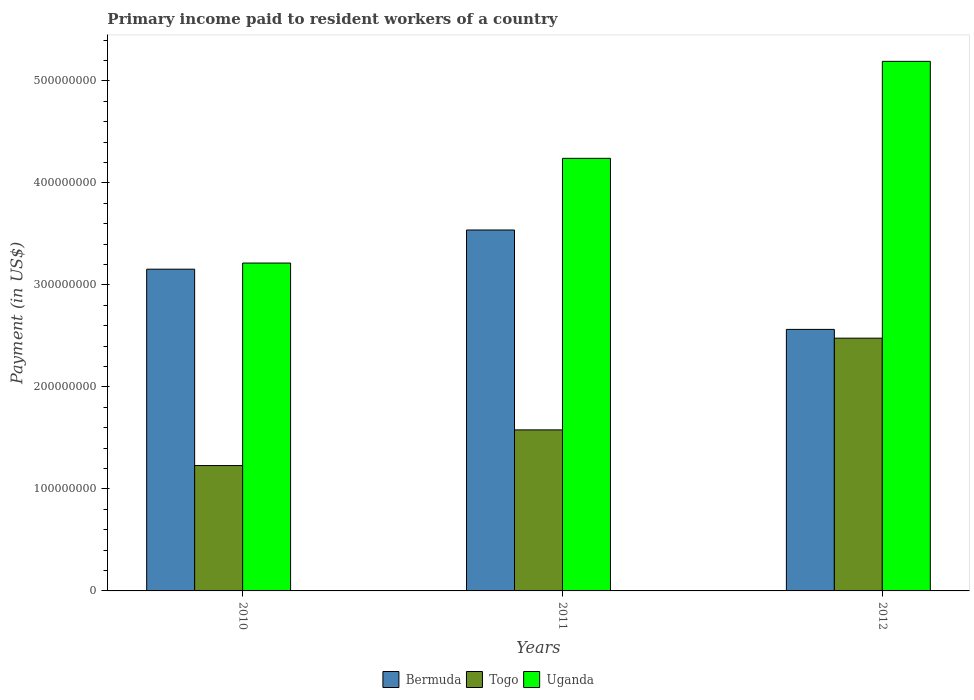What is the label of the 3rd group of bars from the left?
Provide a short and direct response. 2012. What is the amount paid to workers in Uganda in 2012?
Make the answer very short. 5.19e+08. Across all years, what is the maximum amount paid to workers in Bermuda?
Your answer should be compact. 3.54e+08. Across all years, what is the minimum amount paid to workers in Uganda?
Your answer should be very brief. 3.21e+08. What is the total amount paid to workers in Uganda in the graph?
Your answer should be compact. 1.26e+09. What is the difference between the amount paid to workers in Togo in 2010 and that in 2011?
Provide a short and direct response. -3.50e+07. What is the difference between the amount paid to workers in Bermuda in 2011 and the amount paid to workers in Togo in 2012?
Make the answer very short. 1.06e+08. What is the average amount paid to workers in Uganda per year?
Give a very brief answer. 4.22e+08. In the year 2011, what is the difference between the amount paid to workers in Uganda and amount paid to workers in Togo?
Your response must be concise. 2.66e+08. What is the ratio of the amount paid to workers in Togo in 2010 to that in 2011?
Keep it short and to the point. 0.78. Is the amount paid to workers in Uganda in 2010 less than that in 2012?
Give a very brief answer. Yes. Is the difference between the amount paid to workers in Uganda in 2010 and 2011 greater than the difference between the amount paid to workers in Togo in 2010 and 2011?
Give a very brief answer. No. What is the difference between the highest and the second highest amount paid to workers in Bermuda?
Ensure brevity in your answer.  3.84e+07. What is the difference between the highest and the lowest amount paid to workers in Bermuda?
Your answer should be very brief. 9.75e+07. In how many years, is the amount paid to workers in Uganda greater than the average amount paid to workers in Uganda taken over all years?
Ensure brevity in your answer.  2. Is the sum of the amount paid to workers in Bermuda in 2011 and 2012 greater than the maximum amount paid to workers in Togo across all years?
Make the answer very short. Yes. What does the 2nd bar from the left in 2012 represents?
Provide a succinct answer. Togo. What does the 2nd bar from the right in 2012 represents?
Your answer should be compact. Togo. How many bars are there?
Offer a very short reply. 9. Are all the bars in the graph horizontal?
Offer a very short reply. No. Are the values on the major ticks of Y-axis written in scientific E-notation?
Keep it short and to the point. No. Does the graph contain any zero values?
Your response must be concise. No. Does the graph contain grids?
Your answer should be compact. No. Where does the legend appear in the graph?
Make the answer very short. Bottom center. How are the legend labels stacked?
Your answer should be very brief. Horizontal. What is the title of the graph?
Make the answer very short. Primary income paid to resident workers of a country. What is the label or title of the X-axis?
Offer a very short reply. Years. What is the label or title of the Y-axis?
Your answer should be compact. Payment (in US$). What is the Payment (in US$) in Bermuda in 2010?
Provide a short and direct response. 3.15e+08. What is the Payment (in US$) in Togo in 2010?
Provide a short and direct response. 1.23e+08. What is the Payment (in US$) in Uganda in 2010?
Your response must be concise. 3.21e+08. What is the Payment (in US$) of Bermuda in 2011?
Make the answer very short. 3.54e+08. What is the Payment (in US$) of Togo in 2011?
Give a very brief answer. 1.58e+08. What is the Payment (in US$) of Uganda in 2011?
Offer a terse response. 4.24e+08. What is the Payment (in US$) in Bermuda in 2012?
Ensure brevity in your answer.  2.56e+08. What is the Payment (in US$) in Togo in 2012?
Make the answer very short. 2.48e+08. What is the Payment (in US$) in Uganda in 2012?
Keep it short and to the point. 5.19e+08. Across all years, what is the maximum Payment (in US$) in Bermuda?
Provide a succinct answer. 3.54e+08. Across all years, what is the maximum Payment (in US$) in Togo?
Your answer should be very brief. 2.48e+08. Across all years, what is the maximum Payment (in US$) in Uganda?
Provide a short and direct response. 5.19e+08. Across all years, what is the minimum Payment (in US$) in Bermuda?
Offer a terse response. 2.56e+08. Across all years, what is the minimum Payment (in US$) in Togo?
Your response must be concise. 1.23e+08. Across all years, what is the minimum Payment (in US$) of Uganda?
Offer a very short reply. 3.21e+08. What is the total Payment (in US$) of Bermuda in the graph?
Provide a succinct answer. 9.26e+08. What is the total Payment (in US$) in Togo in the graph?
Offer a very short reply. 5.29e+08. What is the total Payment (in US$) of Uganda in the graph?
Keep it short and to the point. 1.26e+09. What is the difference between the Payment (in US$) in Bermuda in 2010 and that in 2011?
Your answer should be compact. -3.84e+07. What is the difference between the Payment (in US$) in Togo in 2010 and that in 2011?
Offer a terse response. -3.50e+07. What is the difference between the Payment (in US$) in Uganda in 2010 and that in 2011?
Make the answer very short. -1.03e+08. What is the difference between the Payment (in US$) in Bermuda in 2010 and that in 2012?
Provide a succinct answer. 5.90e+07. What is the difference between the Payment (in US$) in Togo in 2010 and that in 2012?
Your answer should be compact. -1.25e+08. What is the difference between the Payment (in US$) of Uganda in 2010 and that in 2012?
Offer a terse response. -1.98e+08. What is the difference between the Payment (in US$) in Bermuda in 2011 and that in 2012?
Provide a succinct answer. 9.75e+07. What is the difference between the Payment (in US$) in Togo in 2011 and that in 2012?
Your answer should be compact. -8.99e+07. What is the difference between the Payment (in US$) of Uganda in 2011 and that in 2012?
Offer a terse response. -9.51e+07. What is the difference between the Payment (in US$) in Bermuda in 2010 and the Payment (in US$) in Togo in 2011?
Keep it short and to the point. 1.58e+08. What is the difference between the Payment (in US$) in Bermuda in 2010 and the Payment (in US$) in Uganda in 2011?
Make the answer very short. -1.09e+08. What is the difference between the Payment (in US$) in Togo in 2010 and the Payment (in US$) in Uganda in 2011?
Your answer should be compact. -3.01e+08. What is the difference between the Payment (in US$) of Bermuda in 2010 and the Payment (in US$) of Togo in 2012?
Give a very brief answer. 6.76e+07. What is the difference between the Payment (in US$) in Bermuda in 2010 and the Payment (in US$) in Uganda in 2012?
Keep it short and to the point. -2.04e+08. What is the difference between the Payment (in US$) in Togo in 2010 and the Payment (in US$) in Uganda in 2012?
Your answer should be compact. -3.96e+08. What is the difference between the Payment (in US$) of Bermuda in 2011 and the Payment (in US$) of Togo in 2012?
Ensure brevity in your answer.  1.06e+08. What is the difference between the Payment (in US$) of Bermuda in 2011 and the Payment (in US$) of Uganda in 2012?
Provide a succinct answer. -1.65e+08. What is the difference between the Payment (in US$) in Togo in 2011 and the Payment (in US$) in Uganda in 2012?
Give a very brief answer. -3.61e+08. What is the average Payment (in US$) in Bermuda per year?
Offer a very short reply. 3.09e+08. What is the average Payment (in US$) in Togo per year?
Offer a terse response. 1.76e+08. What is the average Payment (in US$) of Uganda per year?
Ensure brevity in your answer.  4.22e+08. In the year 2010, what is the difference between the Payment (in US$) in Bermuda and Payment (in US$) in Togo?
Your answer should be very brief. 1.93e+08. In the year 2010, what is the difference between the Payment (in US$) of Bermuda and Payment (in US$) of Uganda?
Offer a very short reply. -6.00e+06. In the year 2010, what is the difference between the Payment (in US$) of Togo and Payment (in US$) of Uganda?
Provide a succinct answer. -1.99e+08. In the year 2011, what is the difference between the Payment (in US$) in Bermuda and Payment (in US$) in Togo?
Give a very brief answer. 1.96e+08. In the year 2011, what is the difference between the Payment (in US$) in Bermuda and Payment (in US$) in Uganda?
Provide a succinct answer. -7.03e+07. In the year 2011, what is the difference between the Payment (in US$) of Togo and Payment (in US$) of Uganda?
Your answer should be very brief. -2.66e+08. In the year 2012, what is the difference between the Payment (in US$) in Bermuda and Payment (in US$) in Togo?
Your answer should be very brief. 8.60e+06. In the year 2012, what is the difference between the Payment (in US$) of Bermuda and Payment (in US$) of Uganda?
Make the answer very short. -2.63e+08. In the year 2012, what is the difference between the Payment (in US$) of Togo and Payment (in US$) of Uganda?
Your answer should be compact. -2.71e+08. What is the ratio of the Payment (in US$) in Bermuda in 2010 to that in 2011?
Ensure brevity in your answer.  0.89. What is the ratio of the Payment (in US$) in Togo in 2010 to that in 2011?
Offer a terse response. 0.78. What is the ratio of the Payment (in US$) in Uganda in 2010 to that in 2011?
Provide a succinct answer. 0.76. What is the ratio of the Payment (in US$) in Bermuda in 2010 to that in 2012?
Provide a succinct answer. 1.23. What is the ratio of the Payment (in US$) of Togo in 2010 to that in 2012?
Offer a terse response. 0.5. What is the ratio of the Payment (in US$) in Uganda in 2010 to that in 2012?
Your answer should be compact. 0.62. What is the ratio of the Payment (in US$) in Bermuda in 2011 to that in 2012?
Make the answer very short. 1.38. What is the ratio of the Payment (in US$) of Togo in 2011 to that in 2012?
Make the answer very short. 0.64. What is the ratio of the Payment (in US$) of Uganda in 2011 to that in 2012?
Provide a short and direct response. 0.82. What is the difference between the highest and the second highest Payment (in US$) of Bermuda?
Your response must be concise. 3.84e+07. What is the difference between the highest and the second highest Payment (in US$) in Togo?
Provide a succinct answer. 8.99e+07. What is the difference between the highest and the second highest Payment (in US$) of Uganda?
Make the answer very short. 9.51e+07. What is the difference between the highest and the lowest Payment (in US$) of Bermuda?
Offer a terse response. 9.75e+07. What is the difference between the highest and the lowest Payment (in US$) of Togo?
Ensure brevity in your answer.  1.25e+08. What is the difference between the highest and the lowest Payment (in US$) of Uganda?
Offer a terse response. 1.98e+08. 